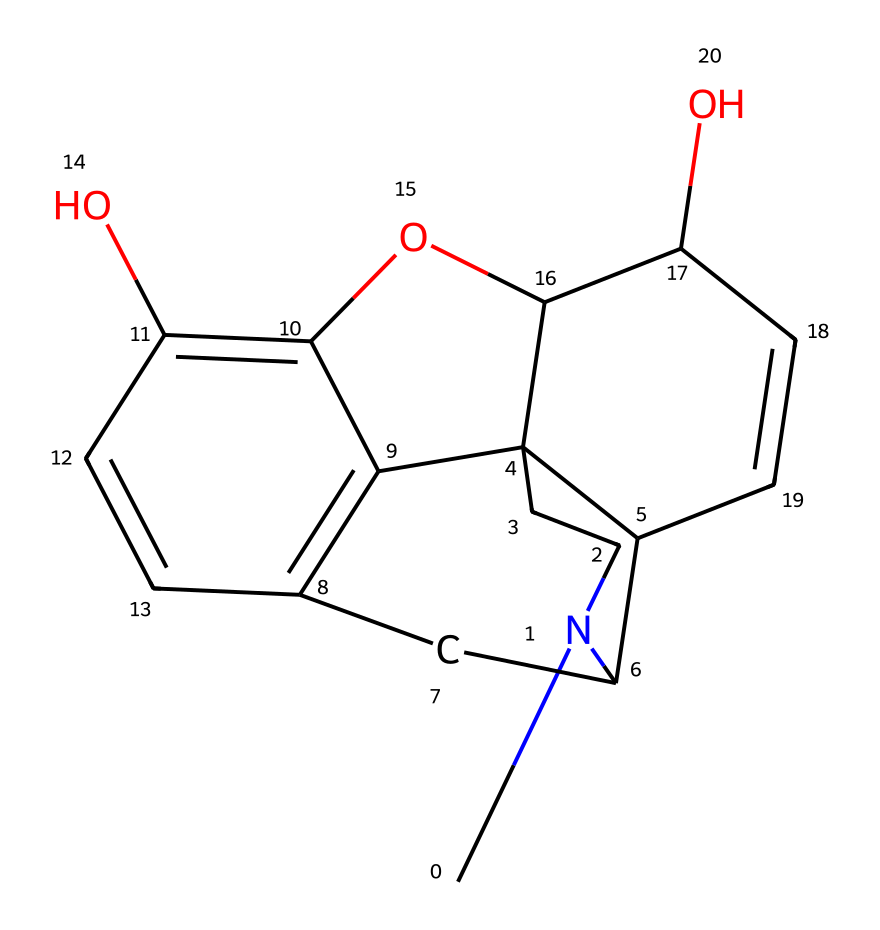What is the molecular formula of morphine? To determine the molecular formula from the SMILES representation, we count the number of each type of atom present. The SMILES breaks down to represent carbon (C), hydrogen (H), nitrogen (N), and oxygen (O) atoms. Counting them gives us C17, H19, N, and O3.
Answer: C17H19NO3 How many rings are present in the chemical structure of morphine? By analyzing the SMILES notation, we can see there are indications of ring closures represented by the numbers. There are four distinct numbers (1, 2, 3, and 4), which means there are four rings formed in this structure.
Answer: 4 What functional groups are present in morphine? Reviewing the structure, we identify that morphine has hydroxyl (-OH) groups and a phenolic structure. These groups are identifiable by the presence of oxygen atoms bonded to hydrogen, indicating the presence of alcohols or phenols.
Answer: hydroxyl groups What is the primary nitrogen atom in morphine indicative of? In alkaloids, the presence of a nitrogen atom typically indicates a basic character and is usually associated with pharmacological activity. In morphine, this nitrogen is key to its function as a pain relief medication.
Answer: basic character How does the presence of multiple hydroxyl groups affect morphine's solubility? The presence of multiple hydroxyl (-OH) groups in the structure increases polarity, enhancing hydrogen bonding with water, thereby increasing morphine's solubility in aqueous solutions. This solubility is critical for its administration as a medication.
Answer: enhances solubility What role do the rings play in the pharmacological activity of morphine? The interconnected rings form a rigid structure that is crucial for binding to opioid receptors in the brain and spinal cord, which is essential for morphine's analgesic effect and overall pharmacological activity.
Answer: critical for binding How does the chemical structure of morphine relate to its classification as an alkaloid? Morphine is classified as an alkaloid due to its nitrogen-containing structure, derived from plant sources, and its physiological activity. The specific arrangement of carbon and nitrogen atoms along with oxygen groups aligns with the characteristics identified in alkaloids.
Answer: classified as alkaloid 